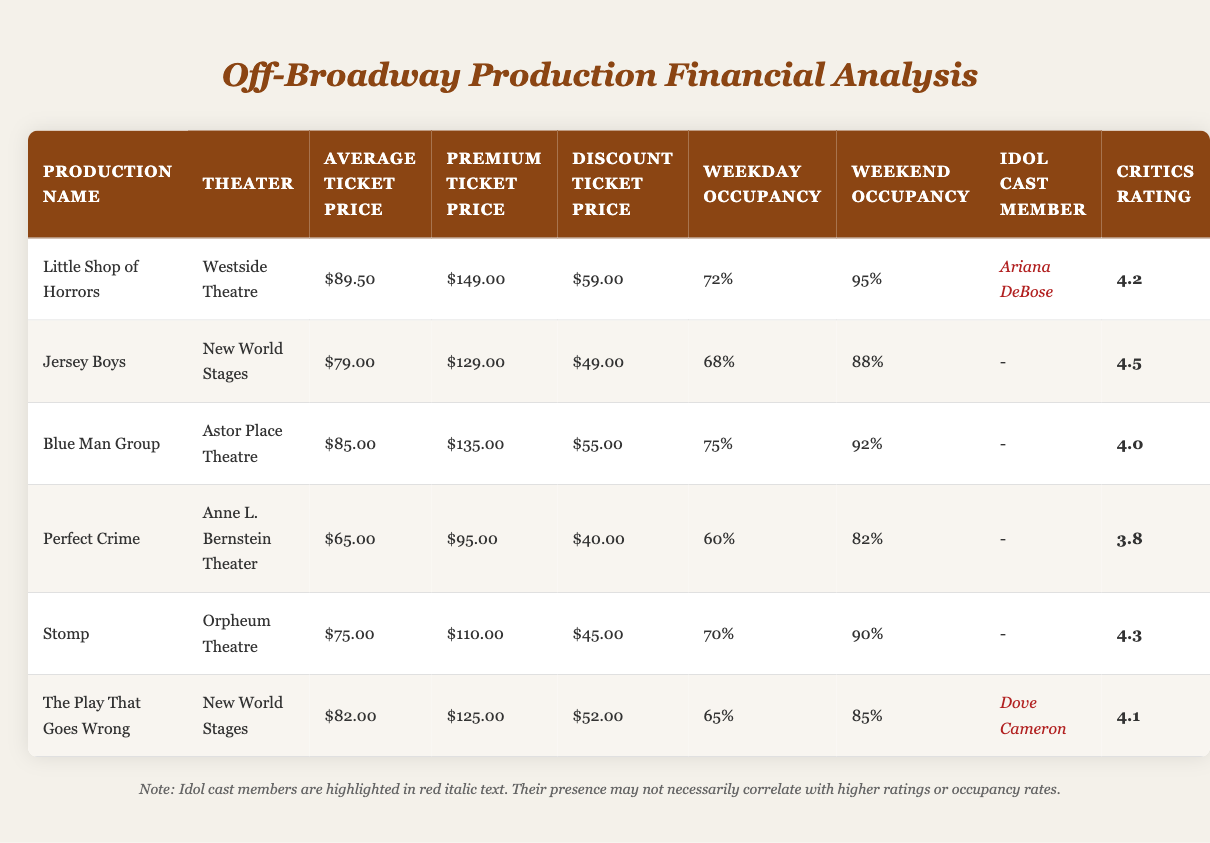What is the average ticket price for "Little Shop of Horrors"? The average ticket price for "Little Shop of Horrors" is directly listed in the table as $89.50.
Answer: $89.50 Which production has the highest weekend occupancy rate? By comparing the weekend occupancy rates of all productions, "Little Shop of Horrors" has the highest rate at 95%.
Answer: 95% Is "Jersey Boys" the only production without an idol cast member? The table shows that Jersey Boys does not have any idol cast member listed (indicated by a dash), while other productions either have idol cast members or are listed with them.
Answer: Yes What is the discount ticket price for "The Play That Goes Wrong"? The discount ticket price for "The Play That Goes Wrong" is clearly stated in the table as $52.00.
Answer: $52.00 What is the average weekday occupancy rate for all productions that feature an idol cast member? The productions with idol cast members are: "Little Shop of Horrors" (72% weekday occupancy) and "The Play That Goes Wrong" (65% weekday occupancy). The average is calculated as (72 + 65) / 2 = 68.5%.
Answer: 68.5% How many productions have an average ticket price below $80.00? In the table, "Perfect Crime" has an average ticket price of $65.00, while "Jersey Boys" ($79.00) is also below $80.00. Therefore, there are two productions with an average below $80.00.
Answer: 2 What is the difference in average ticket price between "Blue Man Group" and "Perfect Crime"? The average ticket price for "Blue Man Group" is $85.00, and for "Perfect Crime," it is $65.00. The difference is calculated as 85 - 65 = 20.
Answer: 20 Which production has the lowest critics rating, and what is that rating? The lowest critics rating in the table is for "Perfect Crime," which is rated at 3.8.
Answer: 3.8 Does "Stomp" have a higher premium ticket price than "Little Shop of Horrors"? The premium ticket price for "Stomp" is $110.00, while for "Little Shop of Horrors," it is $149.00. Thus, "Stomp" does not have a higher premium price.
Answer: No 